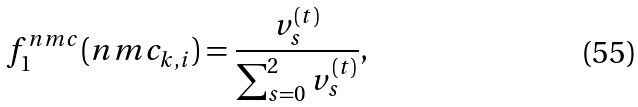<formula> <loc_0><loc_0><loc_500><loc_500>f _ { 1 } ^ { n m c } ( n m c _ { k , i } ) = \frac { v _ { s } ^ { ( t ) } } { \sum _ { s = 0 } ^ { 2 } v _ { s } ^ { ( t ) } } ,</formula> 